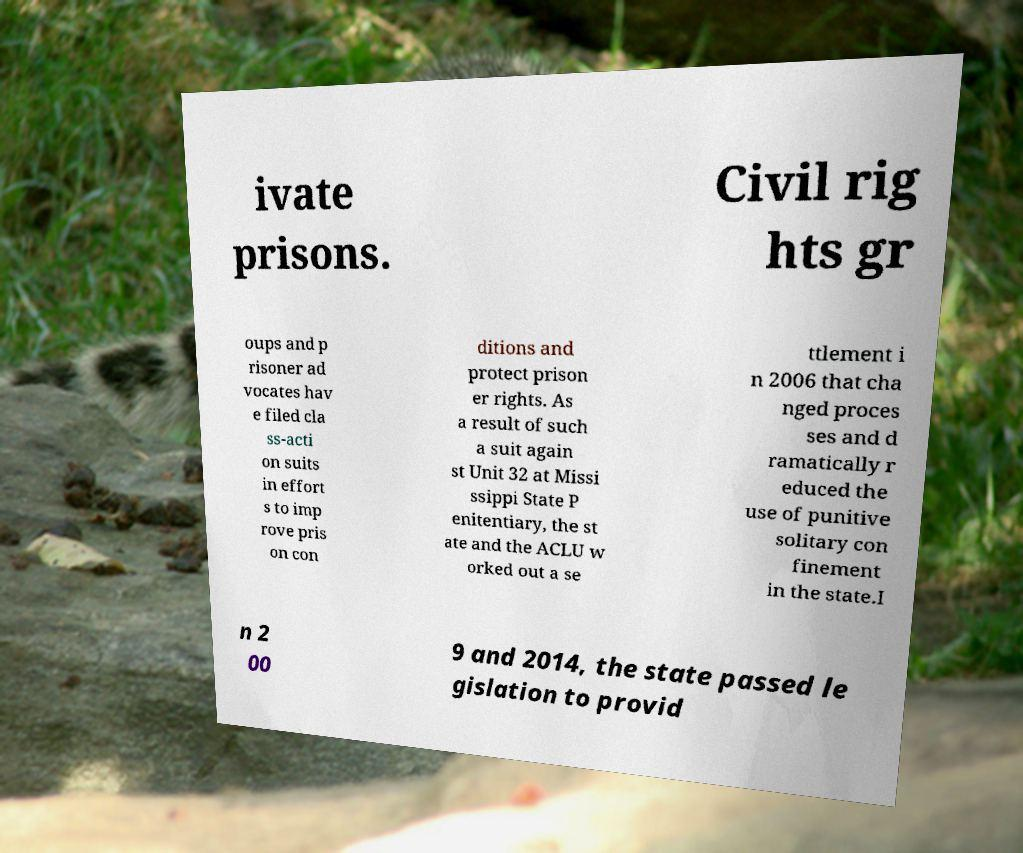Please identify and transcribe the text found in this image. ivate prisons. Civil rig hts gr oups and p risoner ad vocates hav e filed cla ss-acti on suits in effort s to imp rove pris on con ditions and protect prison er rights. As a result of such a suit again st Unit 32 at Missi ssippi State P enitentiary, the st ate and the ACLU w orked out a se ttlement i n 2006 that cha nged proces ses and d ramatically r educed the use of punitive solitary con finement in the state.I n 2 00 9 and 2014, the state passed le gislation to provid 